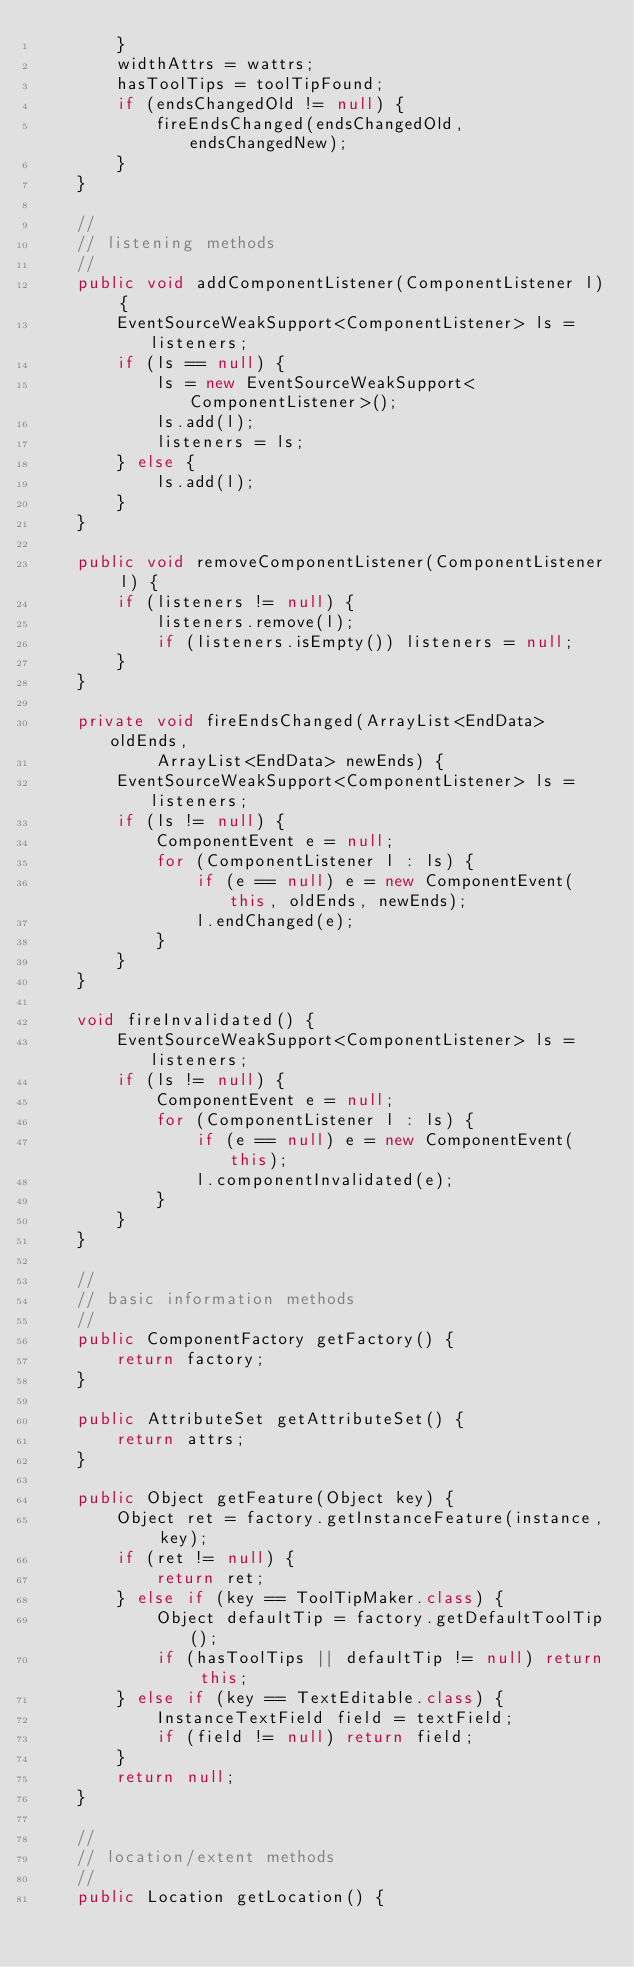Convert code to text. <code><loc_0><loc_0><loc_500><loc_500><_Java_>		}
		widthAttrs = wattrs;
		hasToolTips = toolTipFound;
		if (endsChangedOld != null) {
			fireEndsChanged(endsChangedOld, endsChangedNew);
		}
	}
	
	//
	// listening methods
	//
	public void addComponentListener(ComponentListener l) {
		EventSourceWeakSupport<ComponentListener> ls = listeners;
		if (ls == null) {
			ls = new EventSourceWeakSupport<ComponentListener>();
			ls.add(l);
			listeners = ls;
		} else {
			ls.add(l);
		}
	}

	public void removeComponentListener(ComponentListener l) {
		if (listeners != null) {
			listeners.remove(l);
			if (listeners.isEmpty()) listeners = null;
		}
	}
	
	private void fireEndsChanged(ArrayList<EndData> oldEnds,
			ArrayList<EndData> newEnds) {
		EventSourceWeakSupport<ComponentListener> ls = listeners;
		if (ls != null) {
			ComponentEvent e = null;
			for (ComponentListener l : ls) {
				if (e == null) e = new ComponentEvent(this, oldEnds, newEnds);
				l.endChanged(e);
			}
		}
	}
	
	void fireInvalidated() {
		EventSourceWeakSupport<ComponentListener> ls = listeners;
		if (ls != null) {
			ComponentEvent e = null;
			for (ComponentListener l : ls) {
				if (e == null) e = new ComponentEvent(this);
				l.componentInvalidated(e);
			}
		}
	}

	//
	// basic information methods
	//
	public ComponentFactory getFactory() {
		return factory;
	}

	public AttributeSet getAttributeSet() {
		return attrs;
	}

	public Object getFeature(Object key) {
		Object ret = factory.getInstanceFeature(instance, key);
		if (ret != null) {
			return ret;
		} else if (key == ToolTipMaker.class) {
			Object defaultTip = factory.getDefaultToolTip();
			if (hasToolTips || defaultTip != null) return this;
		} else if (key == TextEditable.class) {
			InstanceTextField field = textField;
			if (field != null) return field;
		}
		return null;
	}

	//
	// location/extent methods
	//
	public Location getLocation() {</code> 